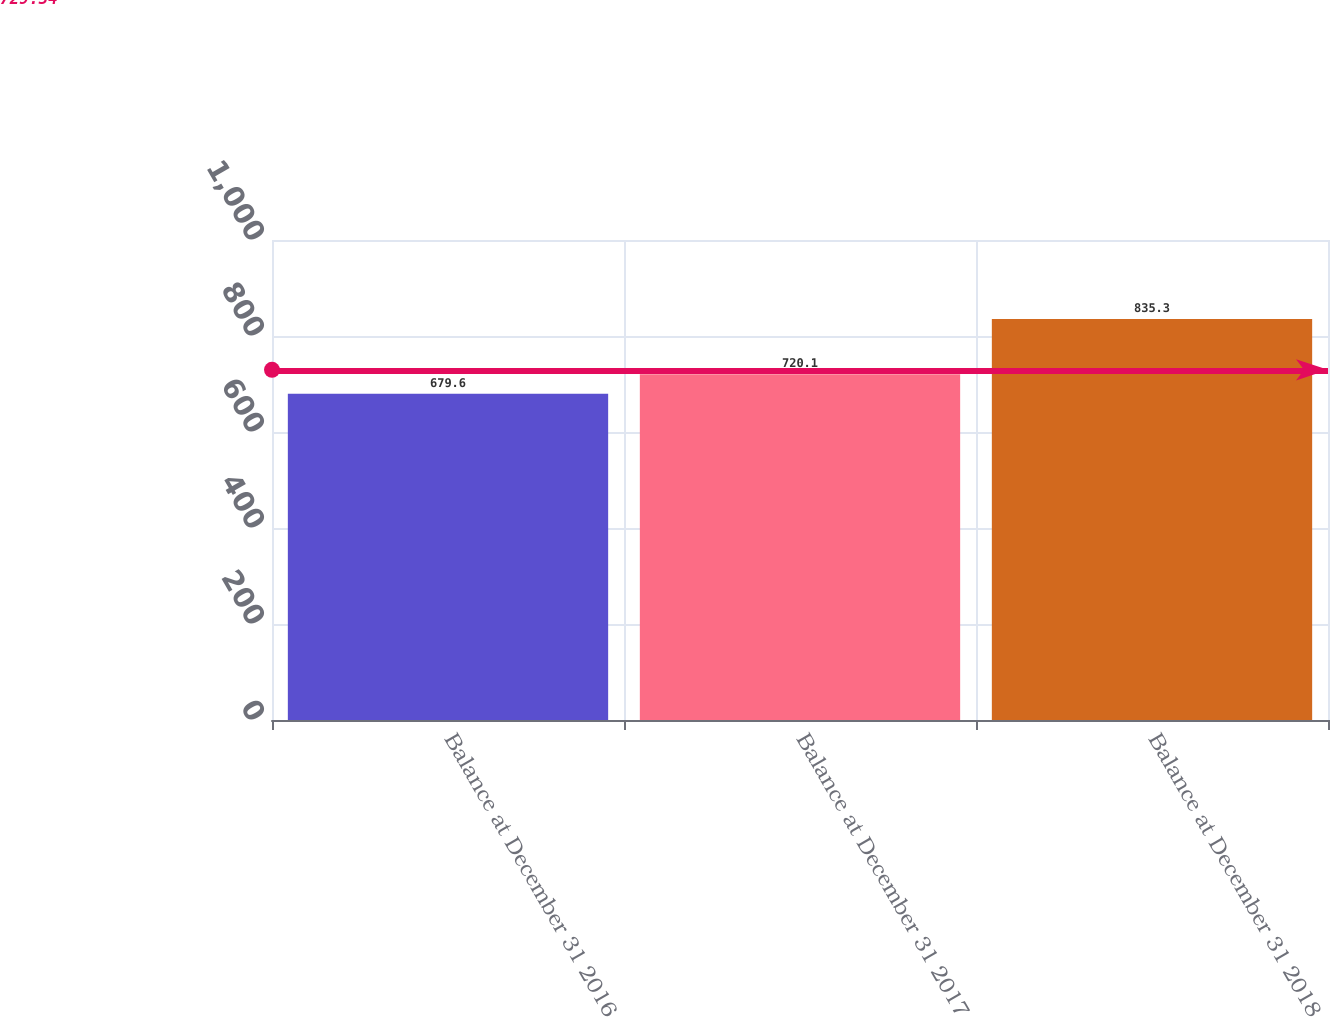Convert chart. <chart><loc_0><loc_0><loc_500><loc_500><bar_chart><fcel>Balance at December 31 2016<fcel>Balance at December 31 2017<fcel>Balance at December 31 2018<nl><fcel>679.6<fcel>720.1<fcel>835.3<nl></chart> 